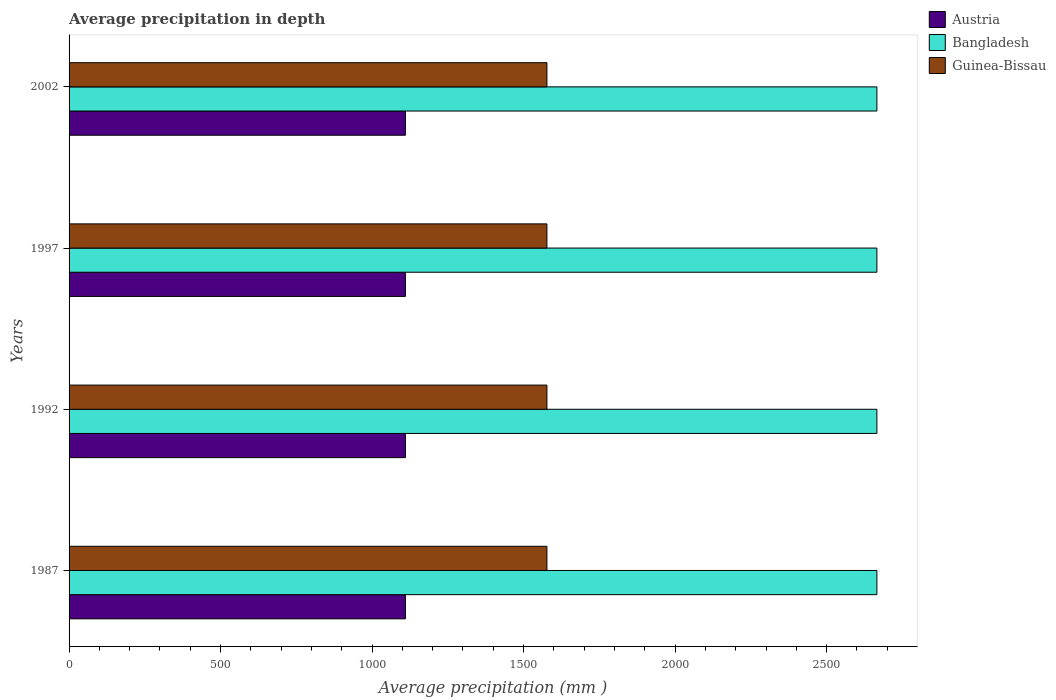What is the label of the 4th group of bars from the top?
Offer a terse response. 1987. What is the average precipitation in Bangladesh in 1992?
Provide a short and direct response. 2666. Across all years, what is the maximum average precipitation in Guinea-Bissau?
Your answer should be compact. 1577. Across all years, what is the minimum average precipitation in Guinea-Bissau?
Give a very brief answer. 1577. In which year was the average precipitation in Bangladesh maximum?
Your answer should be very brief. 1987. In which year was the average precipitation in Austria minimum?
Provide a short and direct response. 1987. What is the total average precipitation in Bangladesh in the graph?
Your response must be concise. 1.07e+04. What is the difference between the average precipitation in Guinea-Bissau in 1987 and that in 1997?
Offer a very short reply. 0. What is the difference between the average precipitation in Guinea-Bissau in 1992 and the average precipitation in Bangladesh in 2002?
Provide a succinct answer. -1089. What is the average average precipitation in Guinea-Bissau per year?
Your response must be concise. 1577. In the year 2002, what is the difference between the average precipitation in Austria and average precipitation in Guinea-Bissau?
Your answer should be very brief. -467. What is the difference between the highest and the lowest average precipitation in Austria?
Offer a terse response. 0. In how many years, is the average precipitation in Guinea-Bissau greater than the average average precipitation in Guinea-Bissau taken over all years?
Provide a short and direct response. 0. Is the sum of the average precipitation in Austria in 1992 and 1997 greater than the maximum average precipitation in Bangladesh across all years?
Provide a short and direct response. No. Is it the case that in every year, the sum of the average precipitation in Bangladesh and average precipitation in Guinea-Bissau is greater than the average precipitation in Austria?
Give a very brief answer. Yes. How many bars are there?
Ensure brevity in your answer.  12. Are all the bars in the graph horizontal?
Offer a terse response. Yes. How many years are there in the graph?
Your response must be concise. 4. What is the difference between two consecutive major ticks on the X-axis?
Give a very brief answer. 500. Are the values on the major ticks of X-axis written in scientific E-notation?
Give a very brief answer. No. Does the graph contain any zero values?
Ensure brevity in your answer.  No. Does the graph contain grids?
Offer a very short reply. No. Where does the legend appear in the graph?
Your answer should be very brief. Top right. What is the title of the graph?
Your response must be concise. Average precipitation in depth. What is the label or title of the X-axis?
Make the answer very short. Average precipitation (mm ). What is the label or title of the Y-axis?
Offer a very short reply. Years. What is the Average precipitation (mm ) of Austria in 1987?
Your answer should be very brief. 1110. What is the Average precipitation (mm ) in Bangladesh in 1987?
Make the answer very short. 2666. What is the Average precipitation (mm ) of Guinea-Bissau in 1987?
Offer a very short reply. 1577. What is the Average precipitation (mm ) of Austria in 1992?
Provide a succinct answer. 1110. What is the Average precipitation (mm ) in Bangladesh in 1992?
Your response must be concise. 2666. What is the Average precipitation (mm ) in Guinea-Bissau in 1992?
Your response must be concise. 1577. What is the Average precipitation (mm ) in Austria in 1997?
Provide a succinct answer. 1110. What is the Average precipitation (mm ) in Bangladesh in 1997?
Give a very brief answer. 2666. What is the Average precipitation (mm ) in Guinea-Bissau in 1997?
Ensure brevity in your answer.  1577. What is the Average precipitation (mm ) of Austria in 2002?
Ensure brevity in your answer.  1110. What is the Average precipitation (mm ) of Bangladesh in 2002?
Provide a short and direct response. 2666. What is the Average precipitation (mm ) of Guinea-Bissau in 2002?
Give a very brief answer. 1577. Across all years, what is the maximum Average precipitation (mm ) of Austria?
Offer a terse response. 1110. Across all years, what is the maximum Average precipitation (mm ) in Bangladesh?
Offer a terse response. 2666. Across all years, what is the maximum Average precipitation (mm ) in Guinea-Bissau?
Make the answer very short. 1577. Across all years, what is the minimum Average precipitation (mm ) of Austria?
Make the answer very short. 1110. Across all years, what is the minimum Average precipitation (mm ) in Bangladesh?
Provide a short and direct response. 2666. Across all years, what is the minimum Average precipitation (mm ) of Guinea-Bissau?
Give a very brief answer. 1577. What is the total Average precipitation (mm ) in Austria in the graph?
Your response must be concise. 4440. What is the total Average precipitation (mm ) in Bangladesh in the graph?
Ensure brevity in your answer.  1.07e+04. What is the total Average precipitation (mm ) in Guinea-Bissau in the graph?
Your response must be concise. 6308. What is the difference between the Average precipitation (mm ) of Austria in 1987 and that in 1992?
Offer a terse response. 0. What is the difference between the Average precipitation (mm ) in Guinea-Bissau in 1987 and that in 1992?
Your answer should be compact. 0. What is the difference between the Average precipitation (mm ) of Bangladesh in 1987 and that in 1997?
Your answer should be compact. 0. What is the difference between the Average precipitation (mm ) of Guinea-Bissau in 1987 and that in 2002?
Offer a terse response. 0. What is the difference between the Average precipitation (mm ) of Guinea-Bissau in 1992 and that in 1997?
Your answer should be compact. 0. What is the difference between the Average precipitation (mm ) of Bangladesh in 1992 and that in 2002?
Give a very brief answer. 0. What is the difference between the Average precipitation (mm ) of Guinea-Bissau in 1992 and that in 2002?
Give a very brief answer. 0. What is the difference between the Average precipitation (mm ) of Austria in 1997 and that in 2002?
Your response must be concise. 0. What is the difference between the Average precipitation (mm ) in Austria in 1987 and the Average precipitation (mm ) in Bangladesh in 1992?
Give a very brief answer. -1556. What is the difference between the Average precipitation (mm ) in Austria in 1987 and the Average precipitation (mm ) in Guinea-Bissau in 1992?
Offer a terse response. -467. What is the difference between the Average precipitation (mm ) in Bangladesh in 1987 and the Average precipitation (mm ) in Guinea-Bissau in 1992?
Provide a succinct answer. 1089. What is the difference between the Average precipitation (mm ) in Austria in 1987 and the Average precipitation (mm ) in Bangladesh in 1997?
Ensure brevity in your answer.  -1556. What is the difference between the Average precipitation (mm ) of Austria in 1987 and the Average precipitation (mm ) of Guinea-Bissau in 1997?
Your answer should be very brief. -467. What is the difference between the Average precipitation (mm ) in Bangladesh in 1987 and the Average precipitation (mm ) in Guinea-Bissau in 1997?
Keep it short and to the point. 1089. What is the difference between the Average precipitation (mm ) of Austria in 1987 and the Average precipitation (mm ) of Bangladesh in 2002?
Give a very brief answer. -1556. What is the difference between the Average precipitation (mm ) in Austria in 1987 and the Average precipitation (mm ) in Guinea-Bissau in 2002?
Offer a terse response. -467. What is the difference between the Average precipitation (mm ) in Bangladesh in 1987 and the Average precipitation (mm ) in Guinea-Bissau in 2002?
Give a very brief answer. 1089. What is the difference between the Average precipitation (mm ) in Austria in 1992 and the Average precipitation (mm ) in Bangladesh in 1997?
Provide a succinct answer. -1556. What is the difference between the Average precipitation (mm ) of Austria in 1992 and the Average precipitation (mm ) of Guinea-Bissau in 1997?
Provide a short and direct response. -467. What is the difference between the Average precipitation (mm ) in Bangladesh in 1992 and the Average precipitation (mm ) in Guinea-Bissau in 1997?
Offer a terse response. 1089. What is the difference between the Average precipitation (mm ) in Austria in 1992 and the Average precipitation (mm ) in Bangladesh in 2002?
Your answer should be very brief. -1556. What is the difference between the Average precipitation (mm ) of Austria in 1992 and the Average precipitation (mm ) of Guinea-Bissau in 2002?
Make the answer very short. -467. What is the difference between the Average precipitation (mm ) of Bangladesh in 1992 and the Average precipitation (mm ) of Guinea-Bissau in 2002?
Your answer should be very brief. 1089. What is the difference between the Average precipitation (mm ) of Austria in 1997 and the Average precipitation (mm ) of Bangladesh in 2002?
Give a very brief answer. -1556. What is the difference between the Average precipitation (mm ) in Austria in 1997 and the Average precipitation (mm ) in Guinea-Bissau in 2002?
Provide a succinct answer. -467. What is the difference between the Average precipitation (mm ) in Bangladesh in 1997 and the Average precipitation (mm ) in Guinea-Bissau in 2002?
Offer a very short reply. 1089. What is the average Average precipitation (mm ) in Austria per year?
Make the answer very short. 1110. What is the average Average precipitation (mm ) in Bangladesh per year?
Ensure brevity in your answer.  2666. What is the average Average precipitation (mm ) of Guinea-Bissau per year?
Provide a short and direct response. 1577. In the year 1987, what is the difference between the Average precipitation (mm ) in Austria and Average precipitation (mm ) in Bangladesh?
Give a very brief answer. -1556. In the year 1987, what is the difference between the Average precipitation (mm ) of Austria and Average precipitation (mm ) of Guinea-Bissau?
Your response must be concise. -467. In the year 1987, what is the difference between the Average precipitation (mm ) of Bangladesh and Average precipitation (mm ) of Guinea-Bissau?
Your response must be concise. 1089. In the year 1992, what is the difference between the Average precipitation (mm ) in Austria and Average precipitation (mm ) in Bangladesh?
Your response must be concise. -1556. In the year 1992, what is the difference between the Average precipitation (mm ) in Austria and Average precipitation (mm ) in Guinea-Bissau?
Offer a very short reply. -467. In the year 1992, what is the difference between the Average precipitation (mm ) of Bangladesh and Average precipitation (mm ) of Guinea-Bissau?
Offer a very short reply. 1089. In the year 1997, what is the difference between the Average precipitation (mm ) of Austria and Average precipitation (mm ) of Bangladesh?
Your answer should be very brief. -1556. In the year 1997, what is the difference between the Average precipitation (mm ) of Austria and Average precipitation (mm ) of Guinea-Bissau?
Provide a succinct answer. -467. In the year 1997, what is the difference between the Average precipitation (mm ) of Bangladesh and Average precipitation (mm ) of Guinea-Bissau?
Provide a succinct answer. 1089. In the year 2002, what is the difference between the Average precipitation (mm ) in Austria and Average precipitation (mm ) in Bangladesh?
Make the answer very short. -1556. In the year 2002, what is the difference between the Average precipitation (mm ) of Austria and Average precipitation (mm ) of Guinea-Bissau?
Keep it short and to the point. -467. In the year 2002, what is the difference between the Average precipitation (mm ) of Bangladesh and Average precipitation (mm ) of Guinea-Bissau?
Provide a short and direct response. 1089. What is the ratio of the Average precipitation (mm ) in Austria in 1987 to that in 1992?
Offer a very short reply. 1. What is the ratio of the Average precipitation (mm ) in Austria in 1987 to that in 1997?
Keep it short and to the point. 1. What is the ratio of the Average precipitation (mm ) in Austria in 1987 to that in 2002?
Make the answer very short. 1. What is the ratio of the Average precipitation (mm ) of Bangladesh in 1987 to that in 2002?
Your response must be concise. 1. What is the ratio of the Average precipitation (mm ) in Guinea-Bissau in 1987 to that in 2002?
Keep it short and to the point. 1. What is the ratio of the Average precipitation (mm ) in Bangladesh in 1992 to that in 2002?
Your response must be concise. 1. What is the ratio of the Average precipitation (mm ) in Guinea-Bissau in 1992 to that in 2002?
Ensure brevity in your answer.  1. What is the ratio of the Average precipitation (mm ) in Austria in 1997 to that in 2002?
Ensure brevity in your answer.  1. What is the ratio of the Average precipitation (mm ) in Bangladesh in 1997 to that in 2002?
Your answer should be compact. 1. What is the difference between the highest and the second highest Average precipitation (mm ) in Bangladesh?
Give a very brief answer. 0. What is the difference between the highest and the lowest Average precipitation (mm ) in Bangladesh?
Offer a very short reply. 0. 